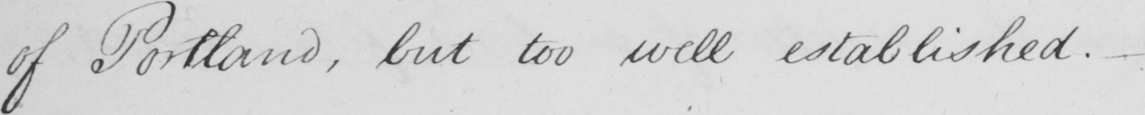What does this handwritten line say? of Portland , but too well established .  _ 